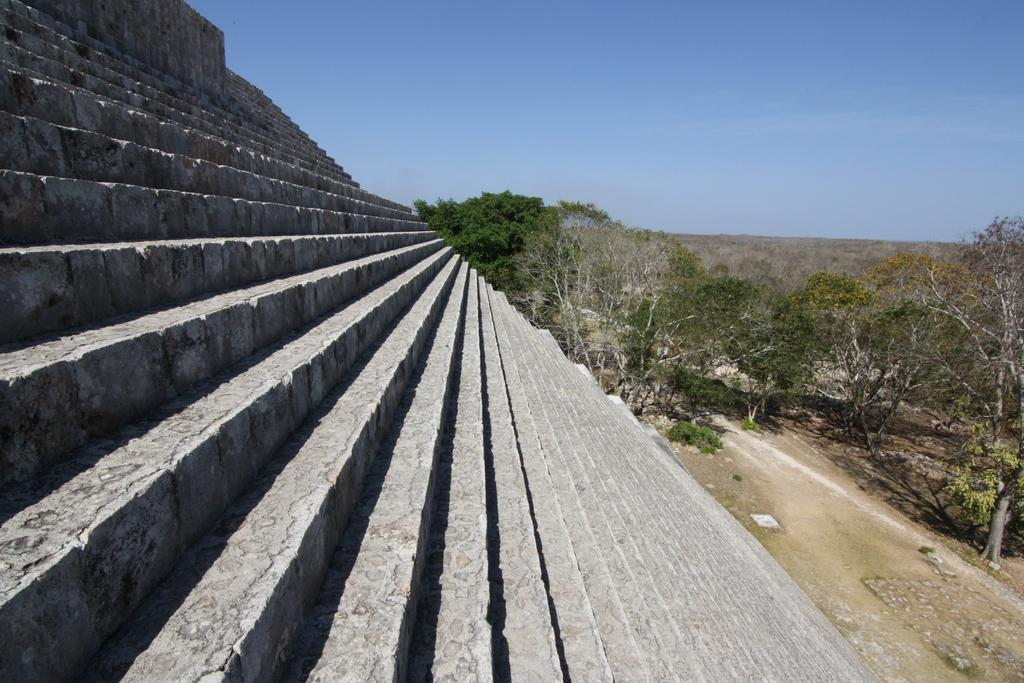What type of architectural feature can be seen in the image? There are steps in the image. What type of natural elements are present in the image? There are trees in the image. What can be seen in the background of the image? The sky is visible in the background of the image. What grade of toothpaste is recommended for the trees in the image? There is no toothpaste or recommendation for toothpaste in the image, as it features steps and trees. What type of pocket can be seen on the trees in the image? There are no pockets present on the trees in the image. 